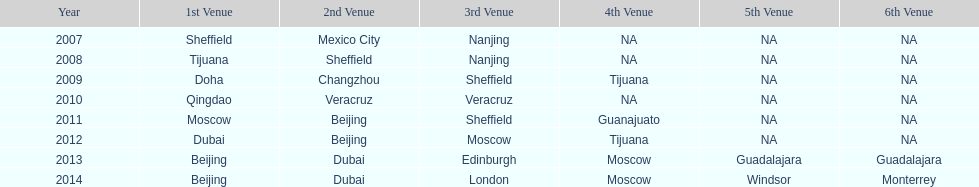In list of venues, how many years was beijing above moscow (1st venue is above 2nd venue, etc)? 3. 